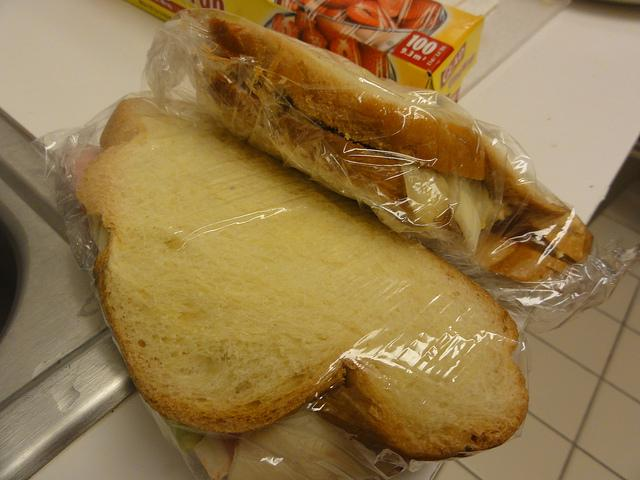What has made the sandwiches to look shiny? plastic wrap 